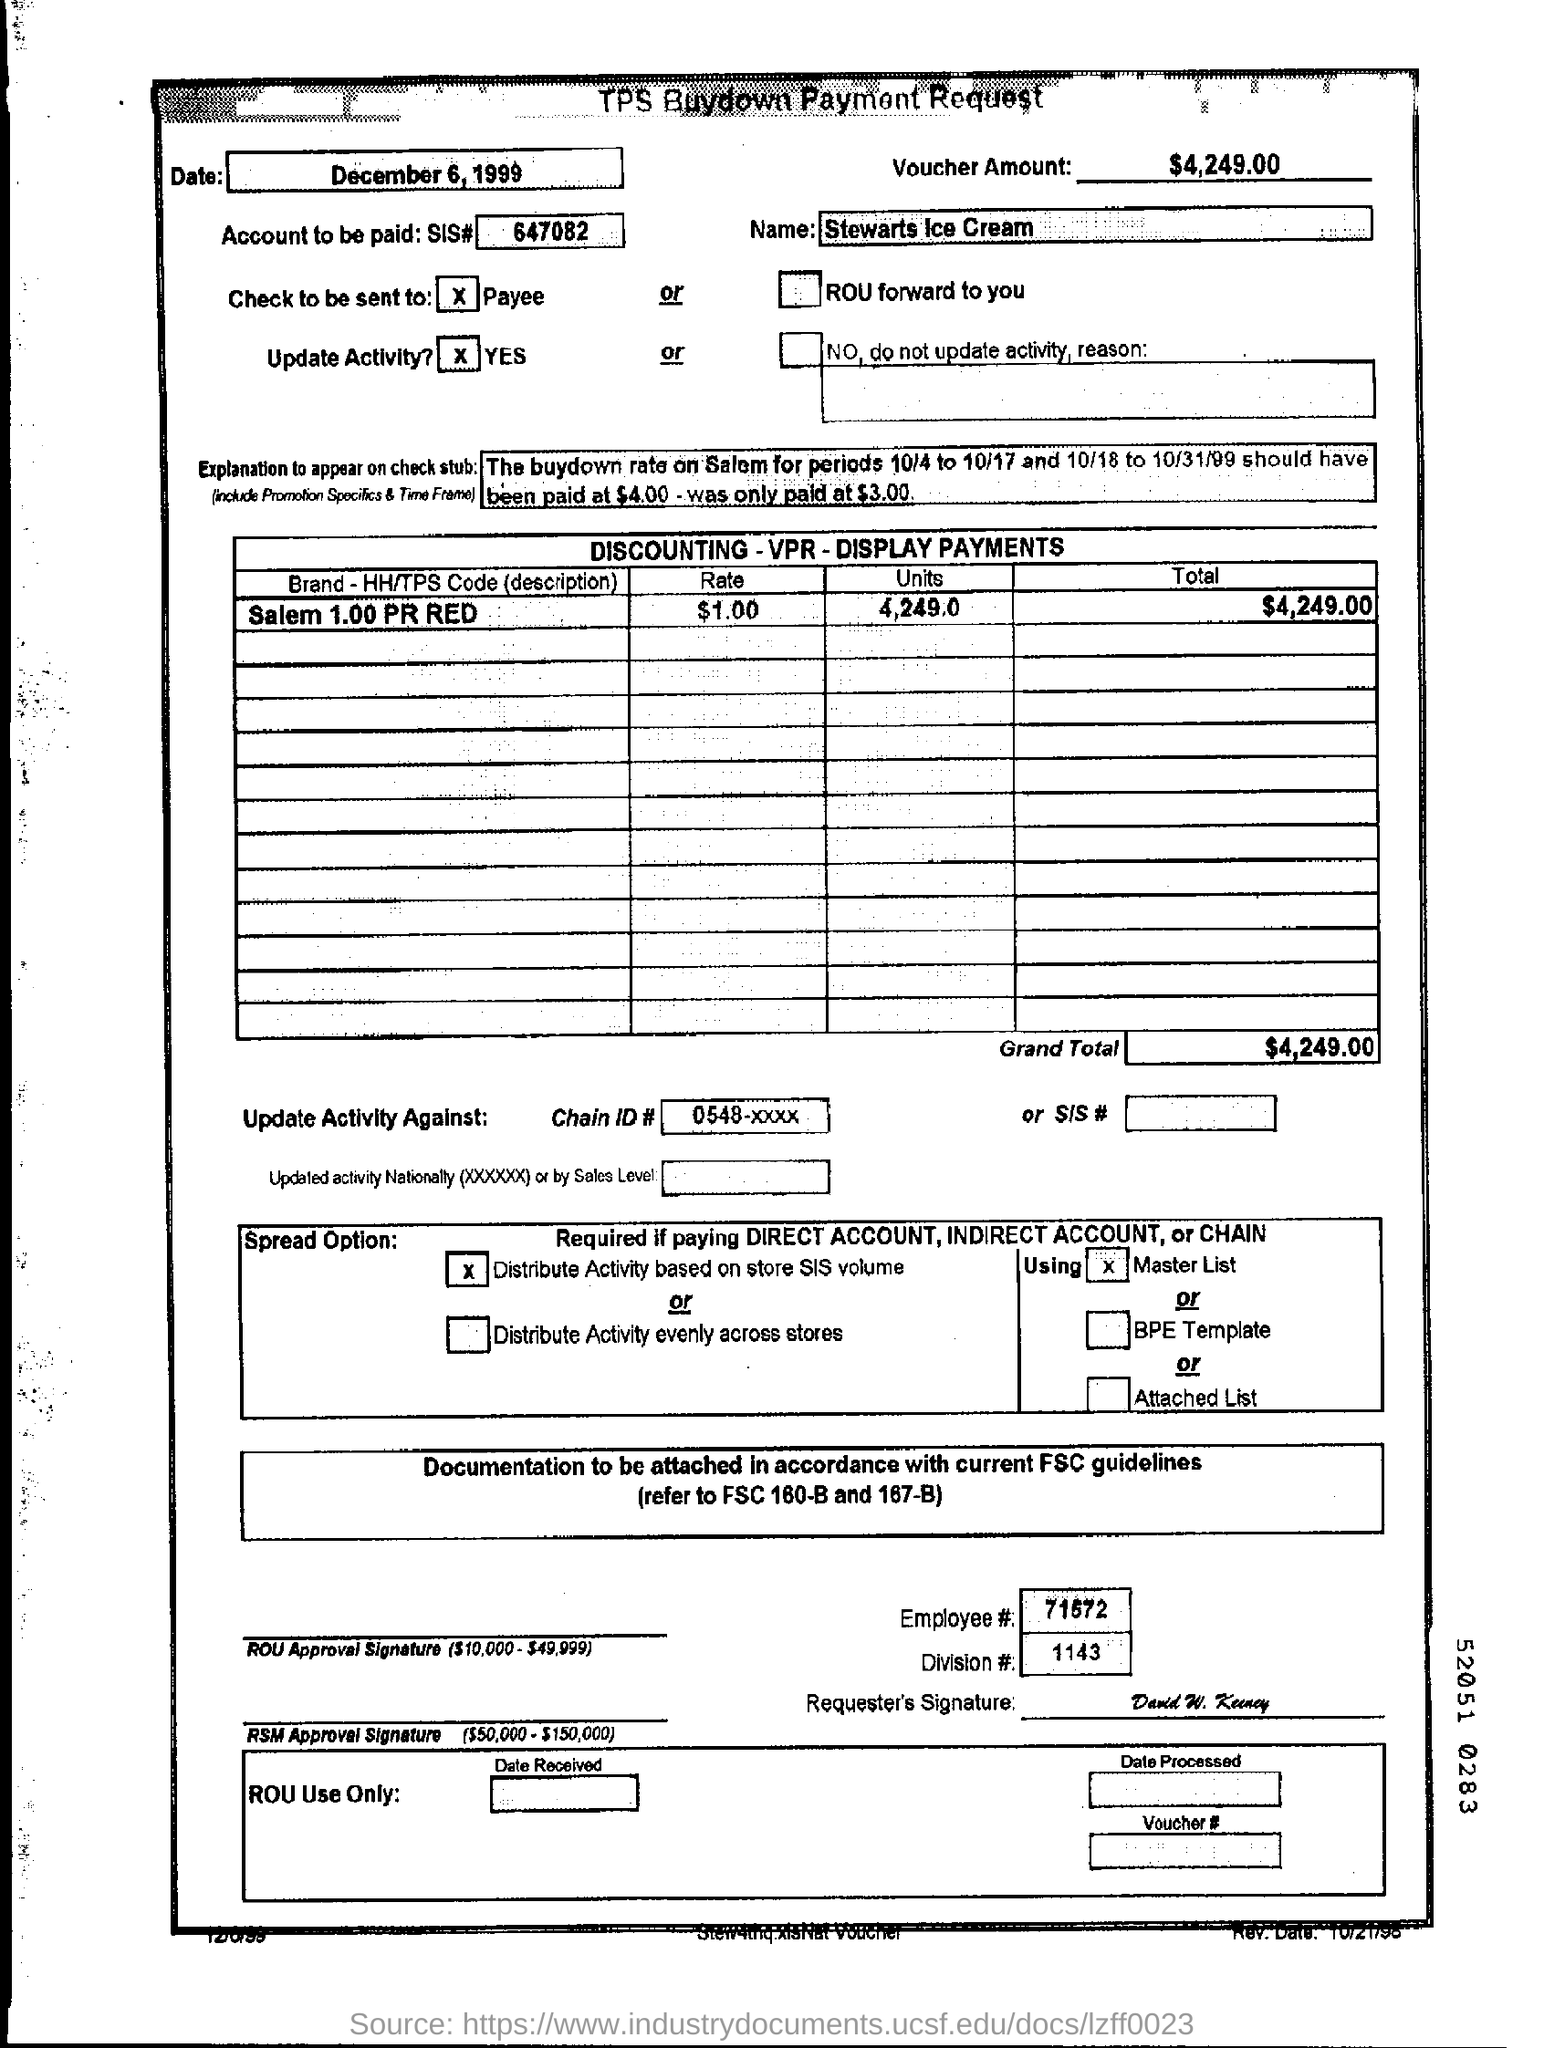Highlight a few significant elements in this photo. The document indicates that the date mentioned is December 6, 1999. The number 71572 belongs to an employee. The voucher amount is $4,249.00. 